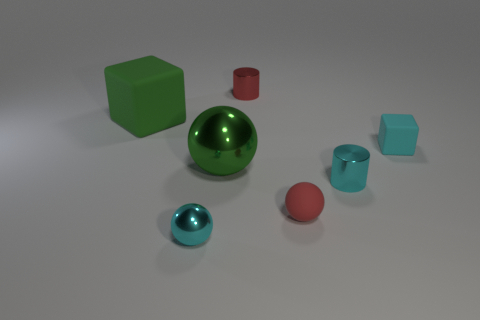What number of tiny things are either blue blocks or things?
Make the answer very short. 5. Do the cyan thing that is on the left side of the small red cylinder and the large green metal thing have the same shape?
Offer a terse response. Yes. Is the number of small cyan cylinders less than the number of small cyan objects?
Your response must be concise. Yes. Is there any other thing that has the same color as the big metal thing?
Keep it short and to the point. Yes. There is a cyan metal thing in front of the small red rubber object; what is its shape?
Give a very brief answer. Sphere. Does the large matte block have the same color as the metallic ball that is behind the tiny red rubber ball?
Offer a very short reply. Yes. Are there an equal number of small objects behind the big cube and cubes that are to the left of the large metal ball?
Offer a terse response. Yes. What number of other things are the same size as the red metal cylinder?
Offer a very short reply. 4. The green shiny thing is what size?
Your answer should be compact. Large. Is the big green block made of the same material as the green object right of the tiny metal ball?
Your response must be concise. No. 